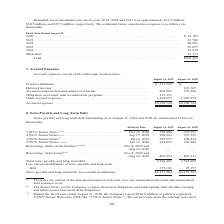According to Jabil Circuit's financial document, What was the contract liabilities in 2019? According to the financial document, $511,329 (in thousands). The relevant text states: "Contract liabilities . $ 511,329 $ — Deferred income . — 691,365 Accrued compensation and employee benefits . 600,907 570,400 Obliga..." Also, What was the Accrued compensation and employee benefits in 2018? According to the financial document, 570,400 (in thousands). The relevant text states: "rued compensation and employee benefits . 600,907 570,400 Obligation associated with securitization programs . 475,251 — Other accrued expenses . 1,402,657 1..." Also, Which years does the table provide information for on accrued expenses? The document shows two values: 2019 and 2018. From the document: "August 31, 2019 August 31, 2018 August 31, 2019 August 31, 2018..." Also, can you calculate: What was the change in Accrued compensation and employee benefits between 2018 and 2019? Based on the calculation: 600,907-570,400, the result is 30507 (in thousands). This is based on the information: "rued compensation and employee benefits . 600,907 570,400 Obligation associated with securitization programs . 475,251 — Other accrued expenses . 1,402,657 1 ,365 Accrued compensation and employee ben..." The key data points involved are: 570,400, 600,907. Also, How many years did accrued expenses exceed $2,000,000 thousand? Counting the relevant items in the document: 2019, 2018, I find 2 instances. The key data points involved are: 2018, 2019. Also, can you calculate: What was the percentage change in accrued expenses between 2018 and 2019? To answer this question, I need to perform calculations using the financial data. The calculation is: ($2,990,144-$2,262,744)/$2,262,744, which equals 32.15 (percentage). This is based on the information: "Accrued expenses . $2,990,144 $2,262,744 Accrued expenses . $2,990,144 $2,262,744..." The key data points involved are: 2,262,744, 2,990,144. 